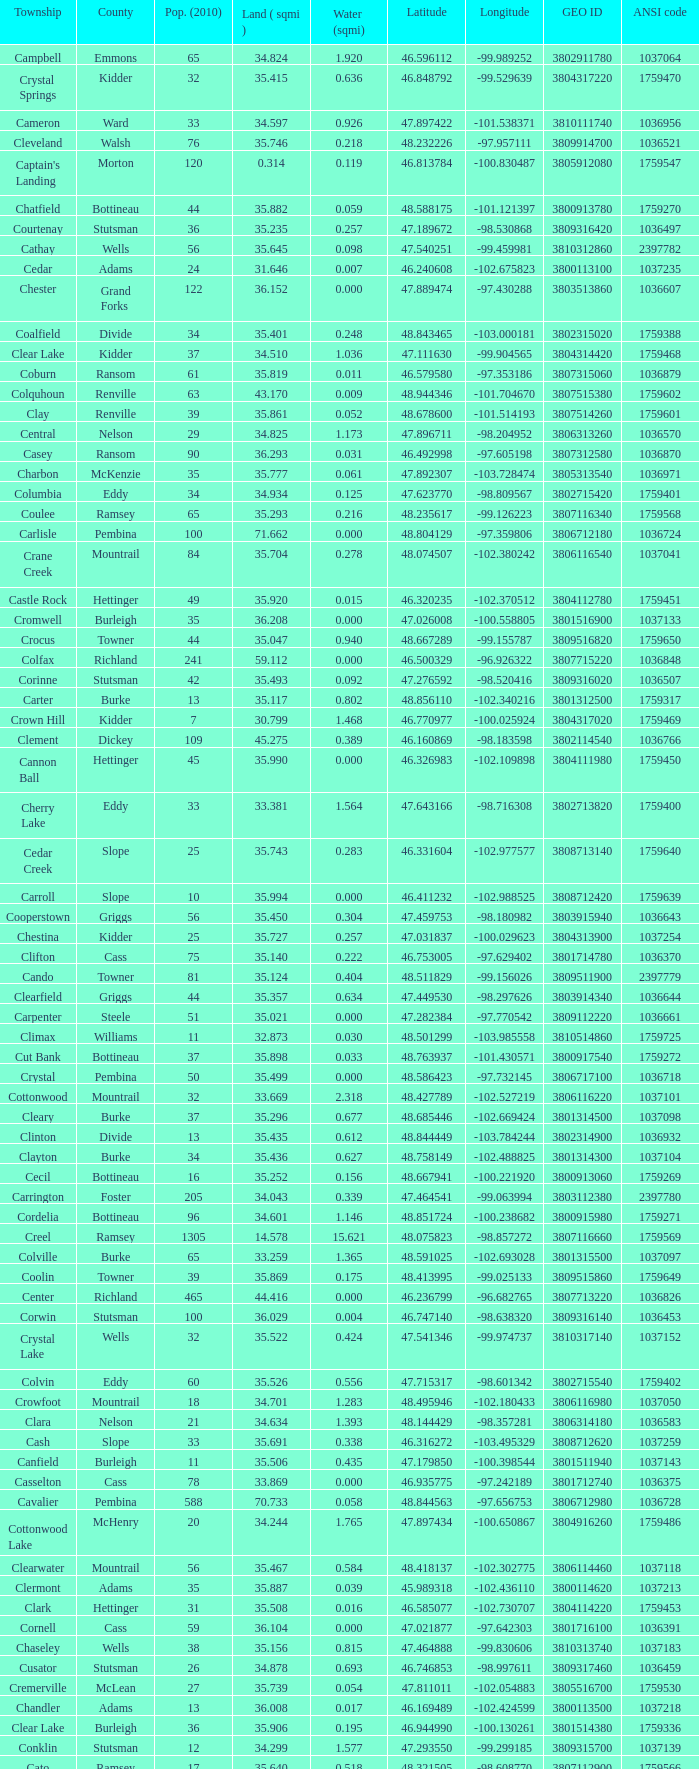What was the latitude of the Clearwater townsship? 48.418137. 